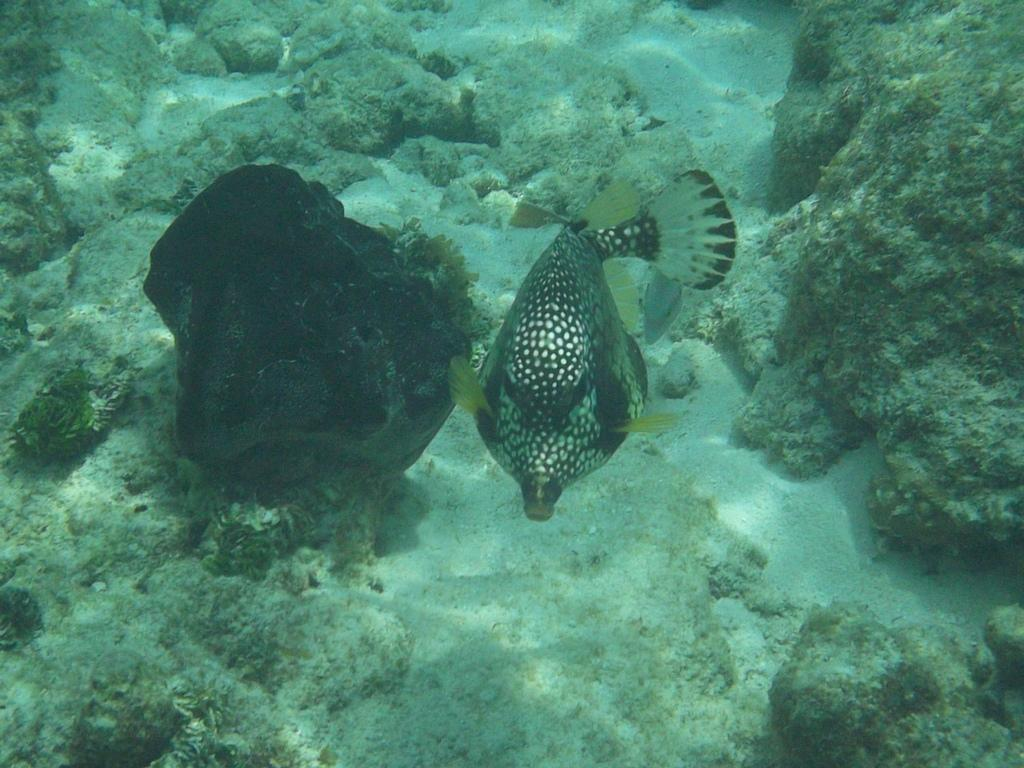What is the main subject of the image? The main subject of the image is a fish. Where is the fish located in the image? The fish is underwater in the image. What type of underwater environment can be seen in the image? There are coral reefs in the image. What type of ink can be seen coming from the fish's finger in the image? There is no fish with a finger present in the image, and therefore no ink can be observed. 